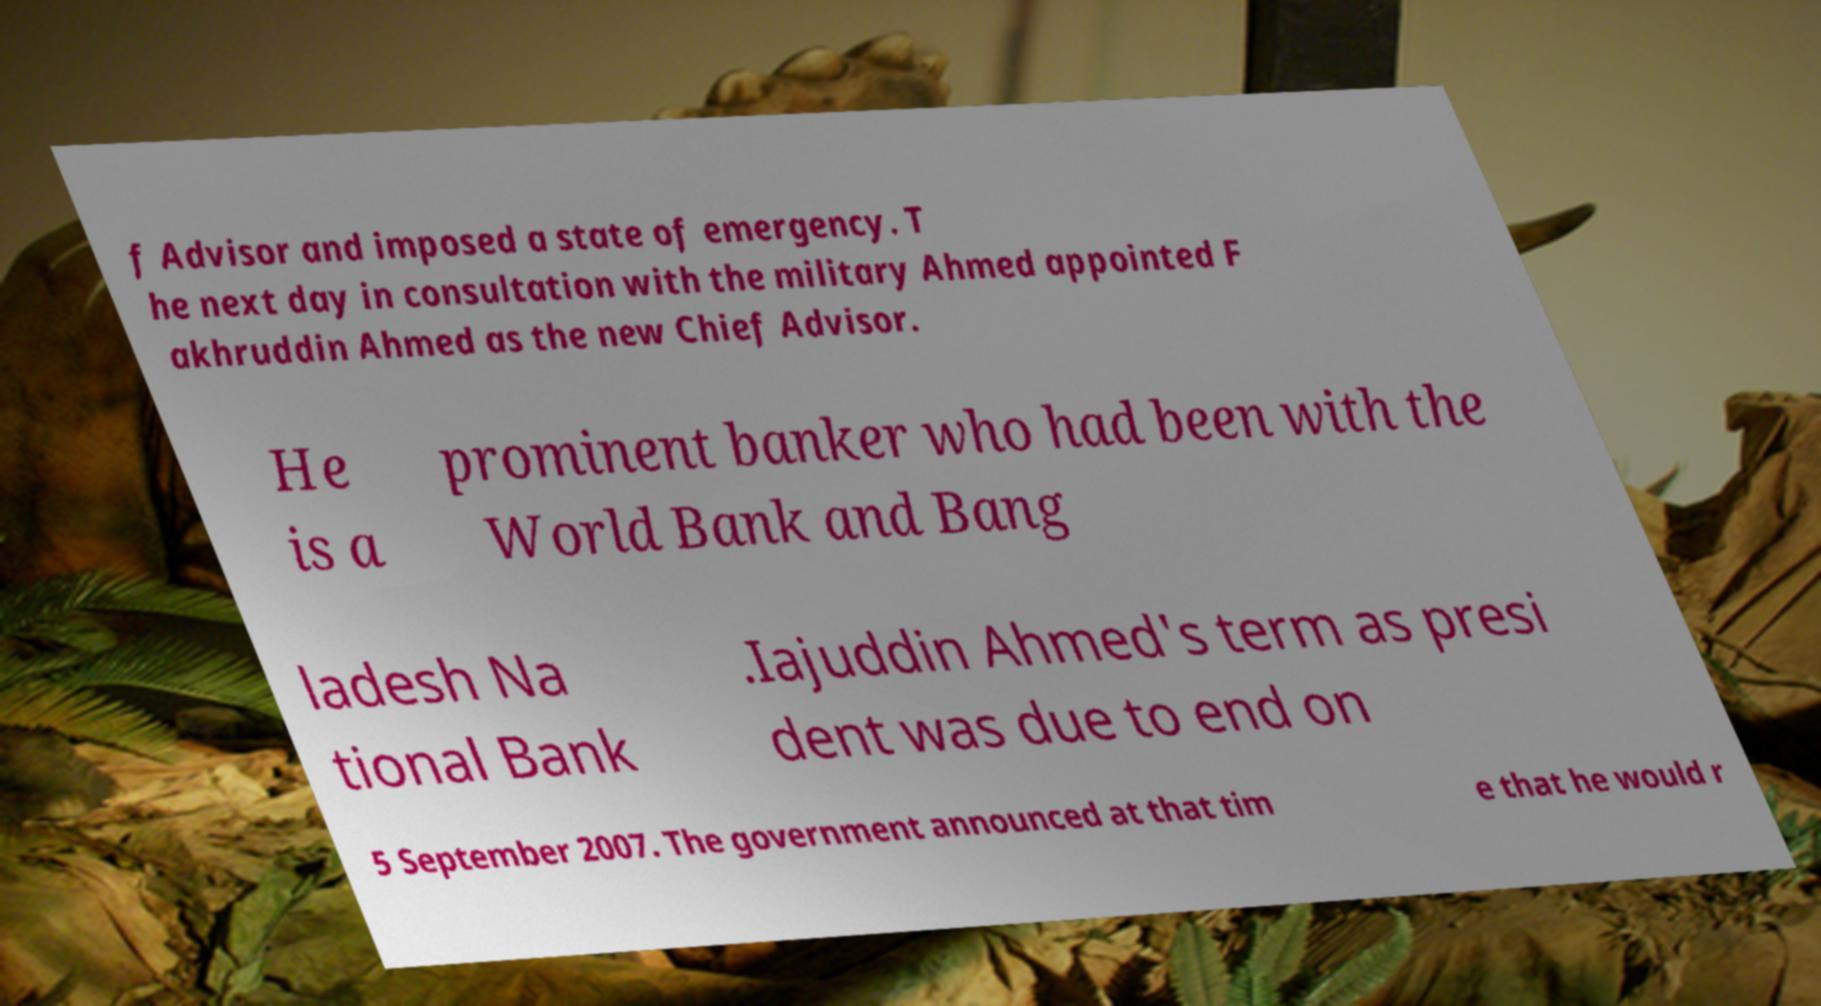There's text embedded in this image that I need extracted. Can you transcribe it verbatim? f Advisor and imposed a state of emergency. T he next day in consultation with the military Ahmed appointed F akhruddin Ahmed as the new Chief Advisor. He is a prominent banker who had been with the World Bank and Bang ladesh Na tional Bank .Iajuddin Ahmed's term as presi dent was due to end on 5 September 2007. The government announced at that tim e that he would r 